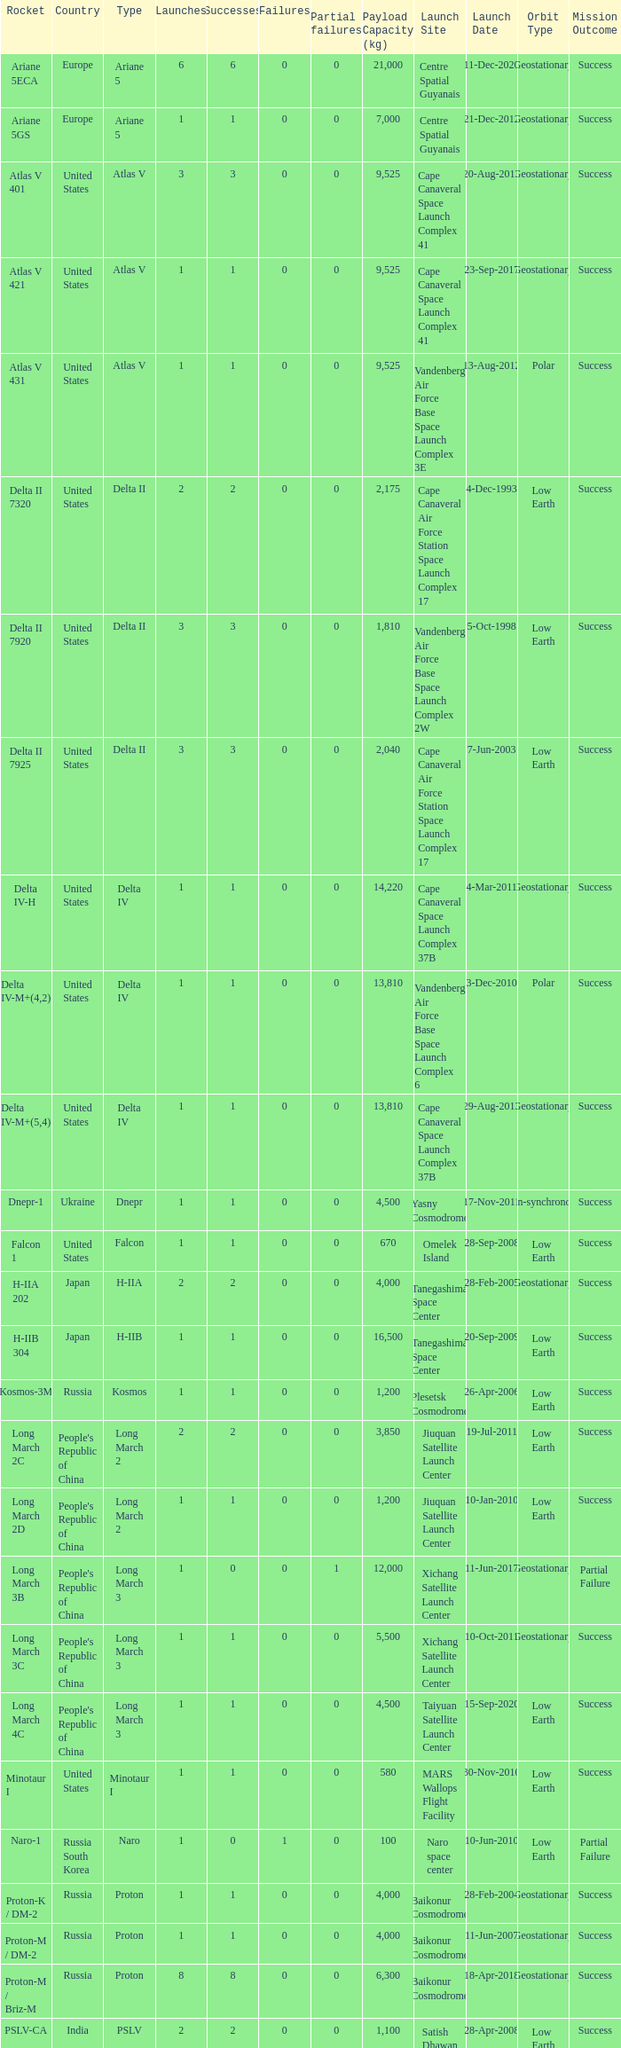What is the number of successes for rockets that have more than 3 launches, were based in Russia, are type soyuz and a rocket type of soyuz-u? 1.0. 